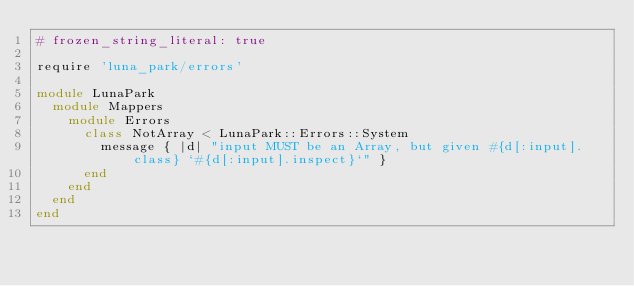Convert code to text. <code><loc_0><loc_0><loc_500><loc_500><_Ruby_># frozen_string_literal: true

require 'luna_park/errors'

module LunaPark
  module Mappers
    module Errors
      class NotArray < LunaPark::Errors::System
        message { |d| "input MUST be an Array, but given #{d[:input].class} `#{d[:input].inspect}`" }
      end
    end
  end
end
</code> 